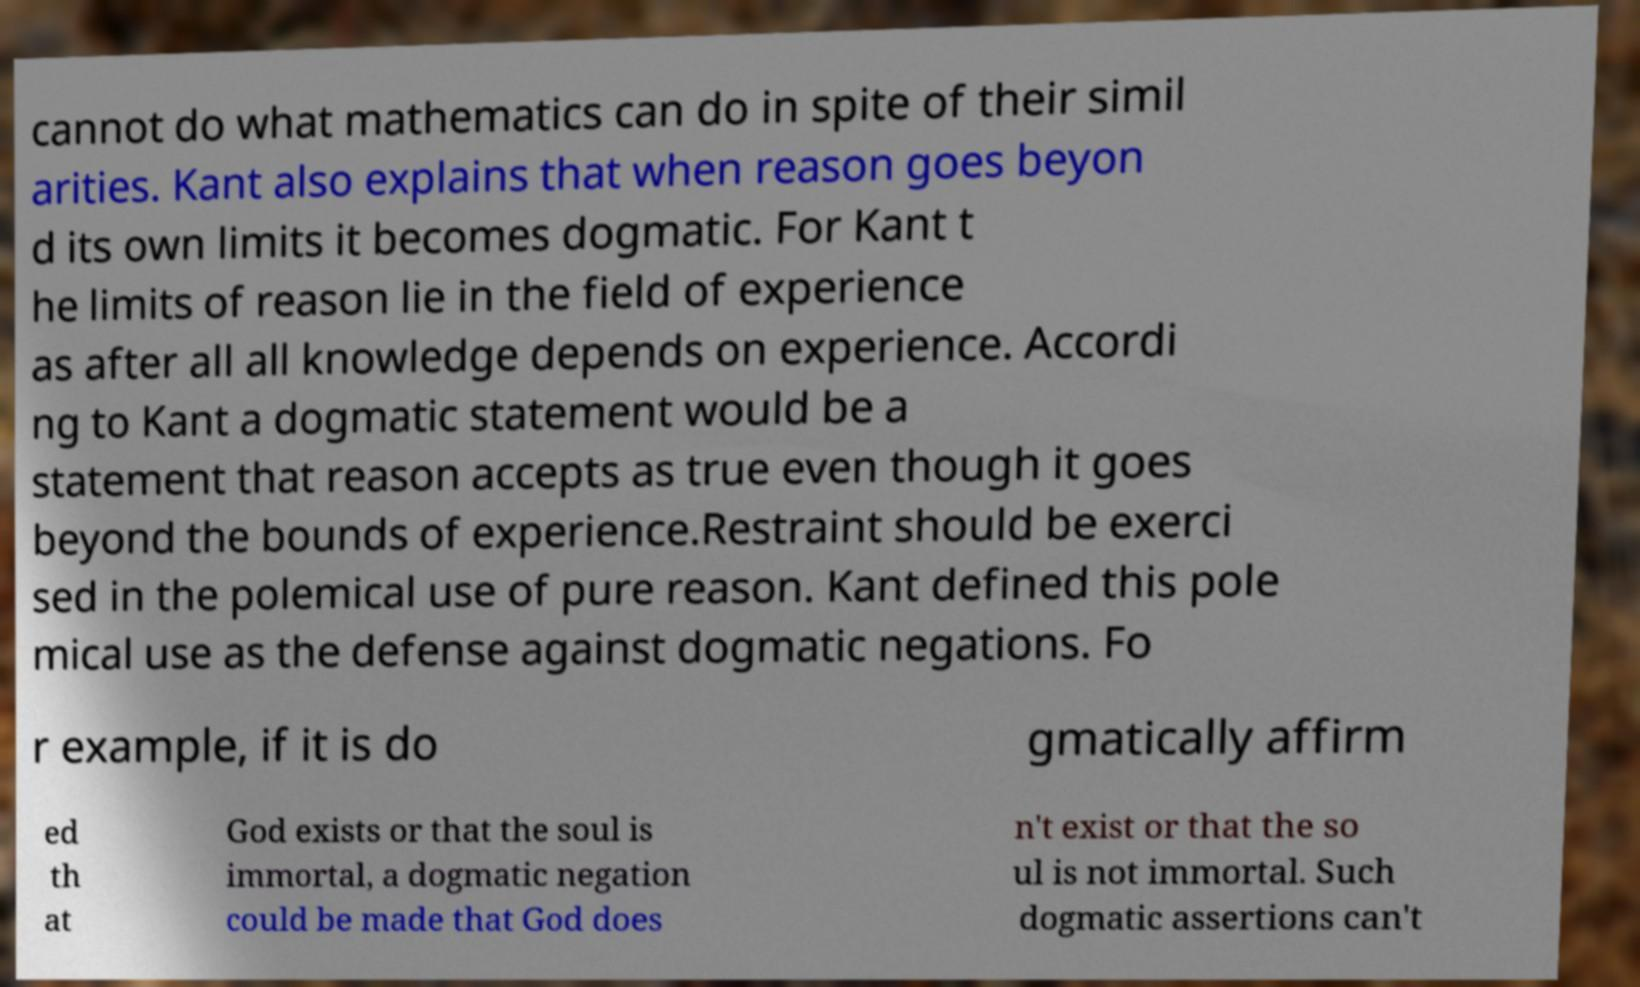I need the written content from this picture converted into text. Can you do that? cannot do what mathematics can do in spite of their simil arities. Kant also explains that when reason goes beyon d its own limits it becomes dogmatic. For Kant t he limits of reason lie in the field of experience as after all all knowledge depends on experience. Accordi ng to Kant a dogmatic statement would be a statement that reason accepts as true even though it goes beyond the bounds of experience.Restraint should be exerci sed in the polemical use of pure reason. Kant defined this pole mical use as the defense against dogmatic negations. Fo r example, if it is do gmatically affirm ed th at God exists or that the soul is immortal, a dogmatic negation could be made that God does n't exist or that the so ul is not immortal. Such dogmatic assertions can't 